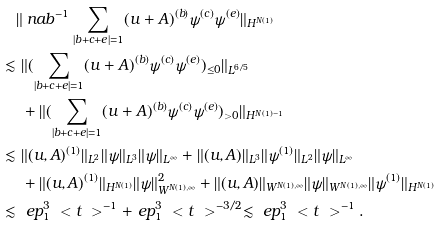Convert formula to latex. <formula><loc_0><loc_0><loc_500><loc_500>& \| \ n a b ^ { - 1 } \sum _ { | b + c + e | = 1 } ( u + A ) ^ { ( b ) } \psi ^ { ( c ) } \psi ^ { ( e ) } \| _ { H ^ { N ( 1 ) } } \\ \lesssim & \ \| ( \sum _ { | b + c + e | = 1 } ( u + A ) ^ { ( b ) } \psi ^ { ( c ) } \psi ^ { ( e ) } ) _ { \leq 0 } \| _ { L ^ { 6 / 5 } } \\ & \ + \| ( \sum _ { | b + c + e | = 1 } ( u + A ) ^ { ( b ) } \psi ^ { ( c ) } \psi ^ { ( e ) } ) _ { > 0 } \| _ { H ^ { N ( 1 ) - 1 } } \\ \lesssim & \ \| ( u , A ) ^ { ( 1 ) } \| _ { L ^ { 2 } } \| \psi \| _ { L ^ { 3 } } \| \psi \| _ { L ^ { \infty } } + \| ( u , A ) \| _ { L ^ { 3 } } \| \psi ^ { ( 1 ) } \| _ { L ^ { 2 } } \| \psi \| _ { L ^ { \infty } } \\ & \ + \| ( u , A ) ^ { ( 1 ) } \| _ { H ^ { N ( 1 ) } } \| \psi \| _ { W ^ { N ( 1 ) , \infty } } ^ { 2 } + \| ( u , A ) \| _ { W ^ { N ( 1 ) , \infty } } \| \psi \| _ { W ^ { N ( 1 ) , \infty } } \| \psi ^ { ( 1 ) } \| _ { H ^ { N ( 1 ) } } \\ \lesssim & \ \ e p _ { 1 } ^ { 3 } \ < t \ > ^ { - 1 } + \ e p _ { 1 } ^ { 3 } \ < t \ > ^ { - 3 / 2 } \lesssim \ e p _ { 1 } ^ { 3 } \ < t \ > ^ { - 1 } .</formula> 